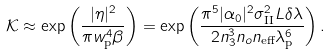<formula> <loc_0><loc_0><loc_500><loc_500>\mathcal { K } \approx \exp \left ( \frac { | \eta | ^ { 2 } } { \pi w _ { \text {p} } ^ { 4 } \beta } \right ) = \exp \left ( \frac { \pi ^ { 5 } | \alpha _ { 0 } | ^ { 2 } \sigma _ { \text {II} } ^ { 2 } L \delta \lambda } { 2 n _ { 3 } ^ { 3 } n _ { o } n _ { \text {eff} } \lambda _ { \text {p} } ^ { 6 } } \right ) .</formula> 